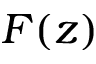<formula> <loc_0><loc_0><loc_500><loc_500>F ( z )</formula> 